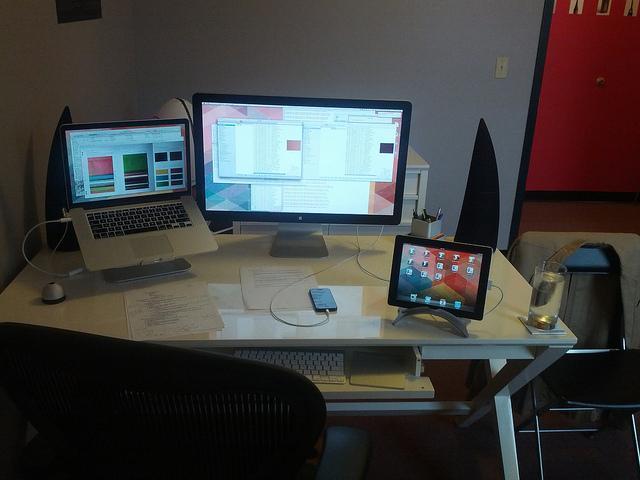What is on the table?
Answer the question by selecting the correct answer among the 4 following choices.
Options: Plate, cat, laptop, fork. Laptop. 